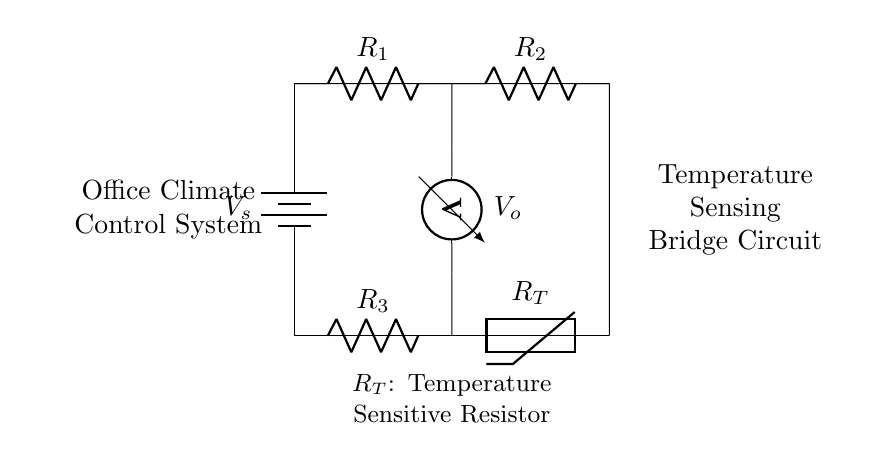What is the power source in this circuit? The circuit uses a battery as its power source, represented by the symbol at the left side of the diagram.
Answer: Battery What component measures voltage in this circuit? The voltmeter is indicated by its specific symbol located on the left side of the lower section of the circuit, and it measures the voltage across the specified nodes.
Answer: Voltmeter Which resistor is temperature-sensitive? The thermistor is clearly labeled as R_T in the circuit, indicating it is the component that varies its resistance with temperature changes.
Answer: R_T How many resistors are present in the circuit? There are three resistors in total, which are labeled as R1, R2, and R3 in the diagram. Each can be counted visually and confirmed by their labels in the circuit.
Answer: Three What is the purpose of the bridge circuit in the context of this diagram? The bridge circuit is designed to compare the resistances of the components to detect changes in temperature, thus allowing for the adjustment of climate control based on those readings.
Answer: Climate control What is the layout of the resistors? The resistors R1 and R2 are placed in series across the top half of the bridge circuit, while R3 and R_T are in series at the bottom half, illustrating a balanced bridge configuration.
Answer: Series What does the output voltage represent? The output voltage \(V_o\) indicates the potential difference measured across two nodes in the circuit, which is affected by the resistances of R1, R2, R3, and the thermistor.
Answer: Output voltage 